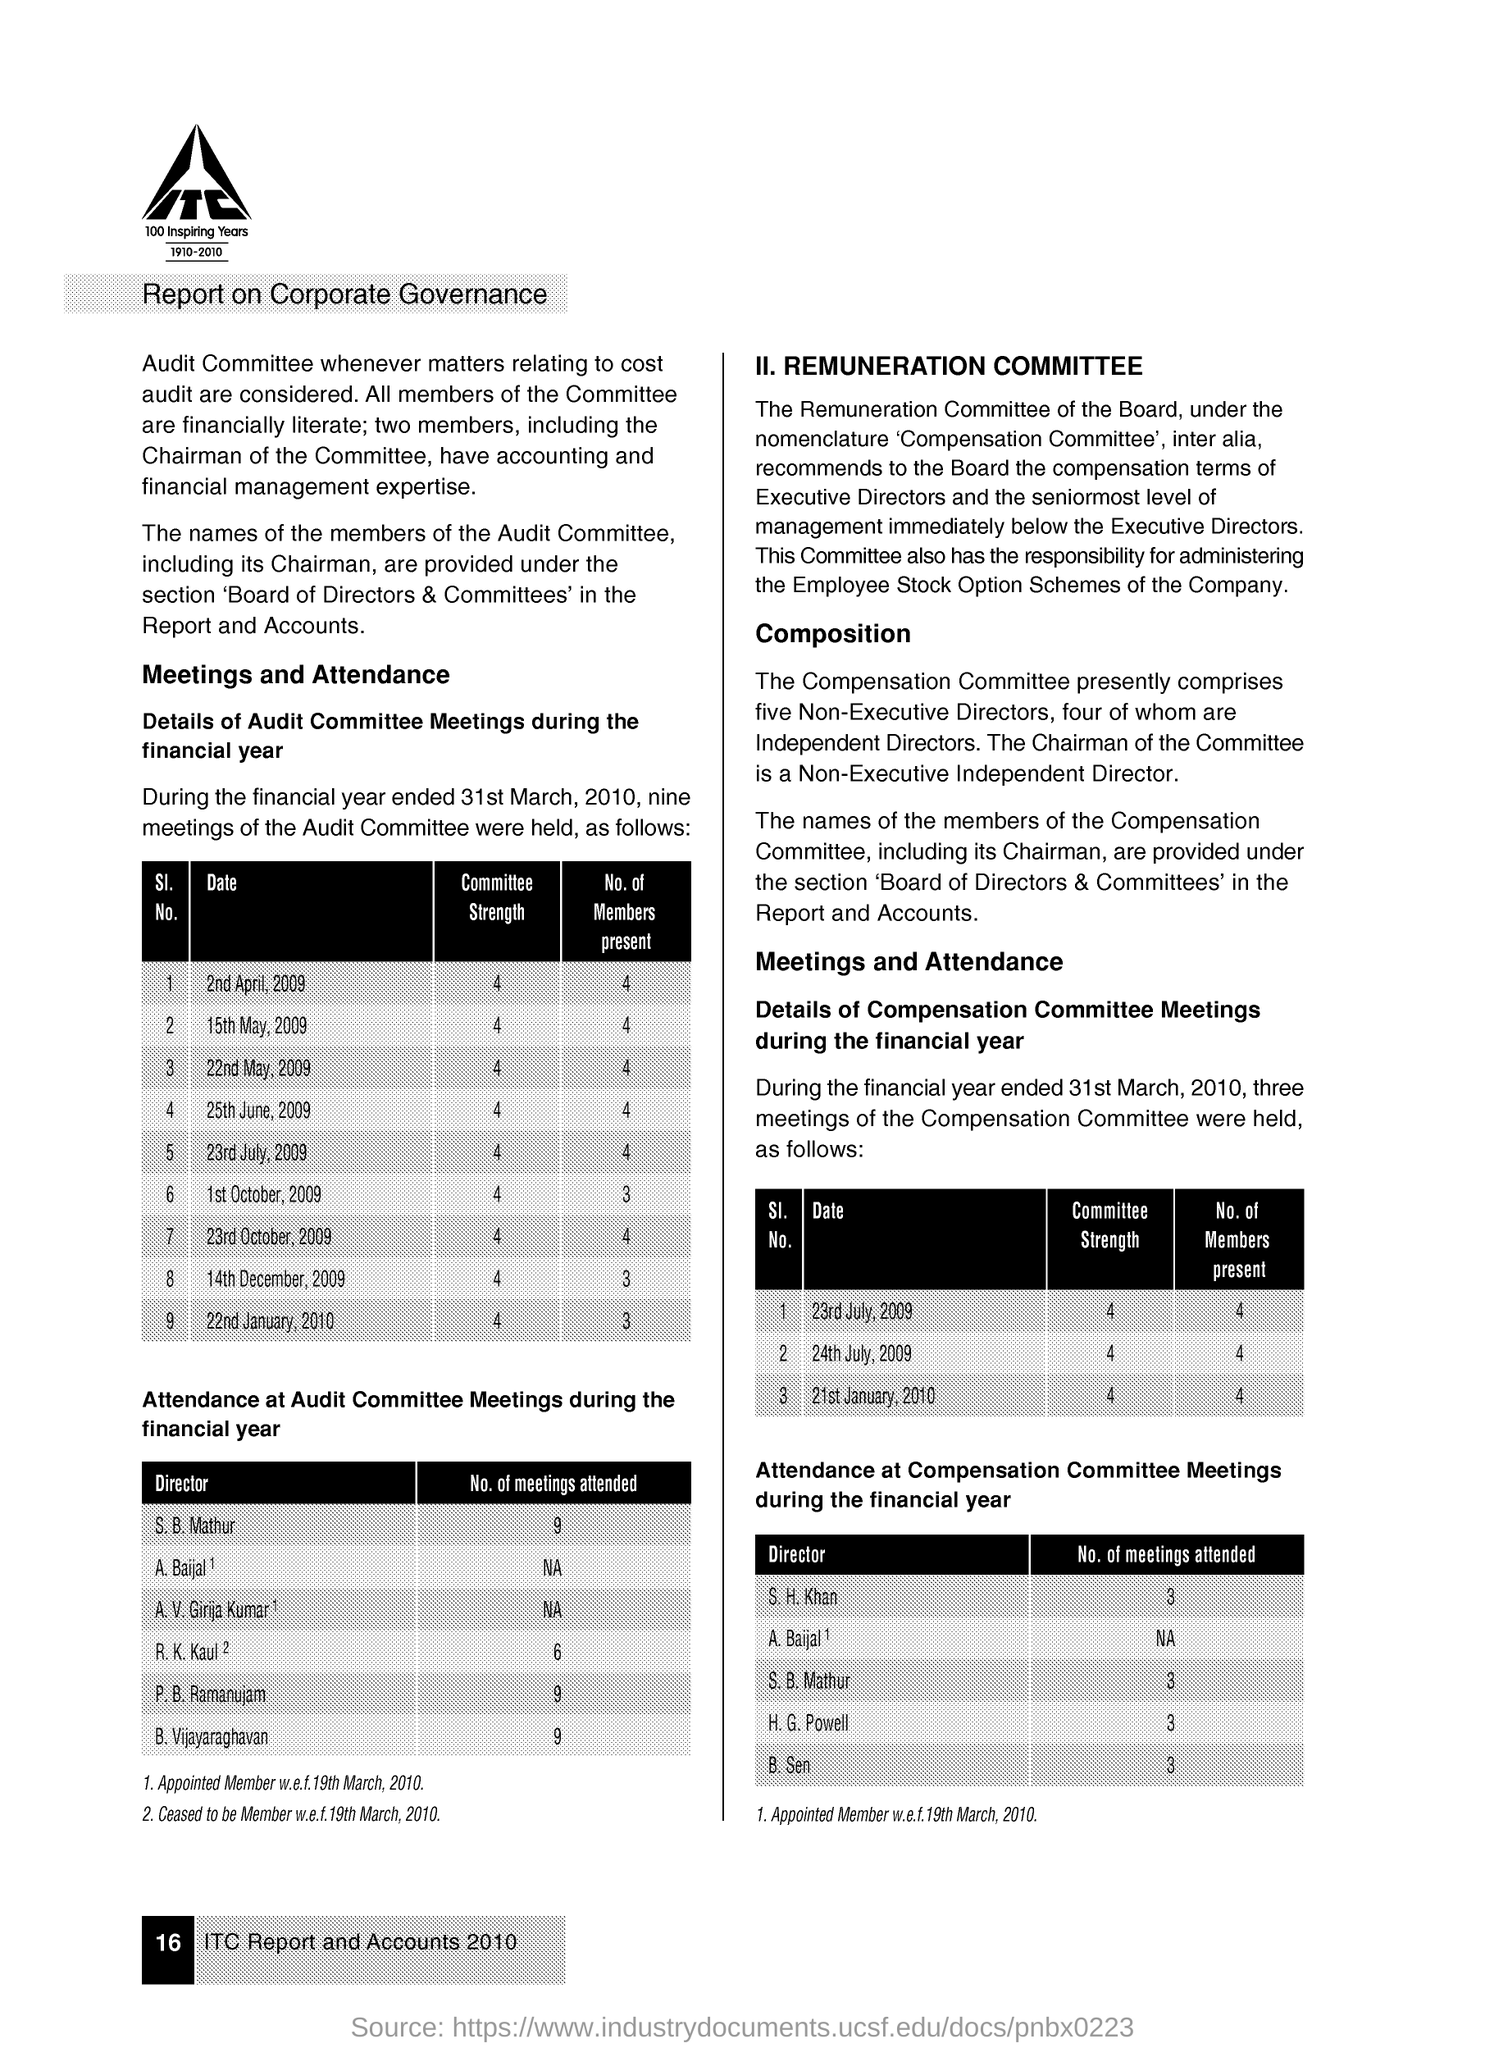The report is on topic?
Offer a terse response. Corporate Governance. 